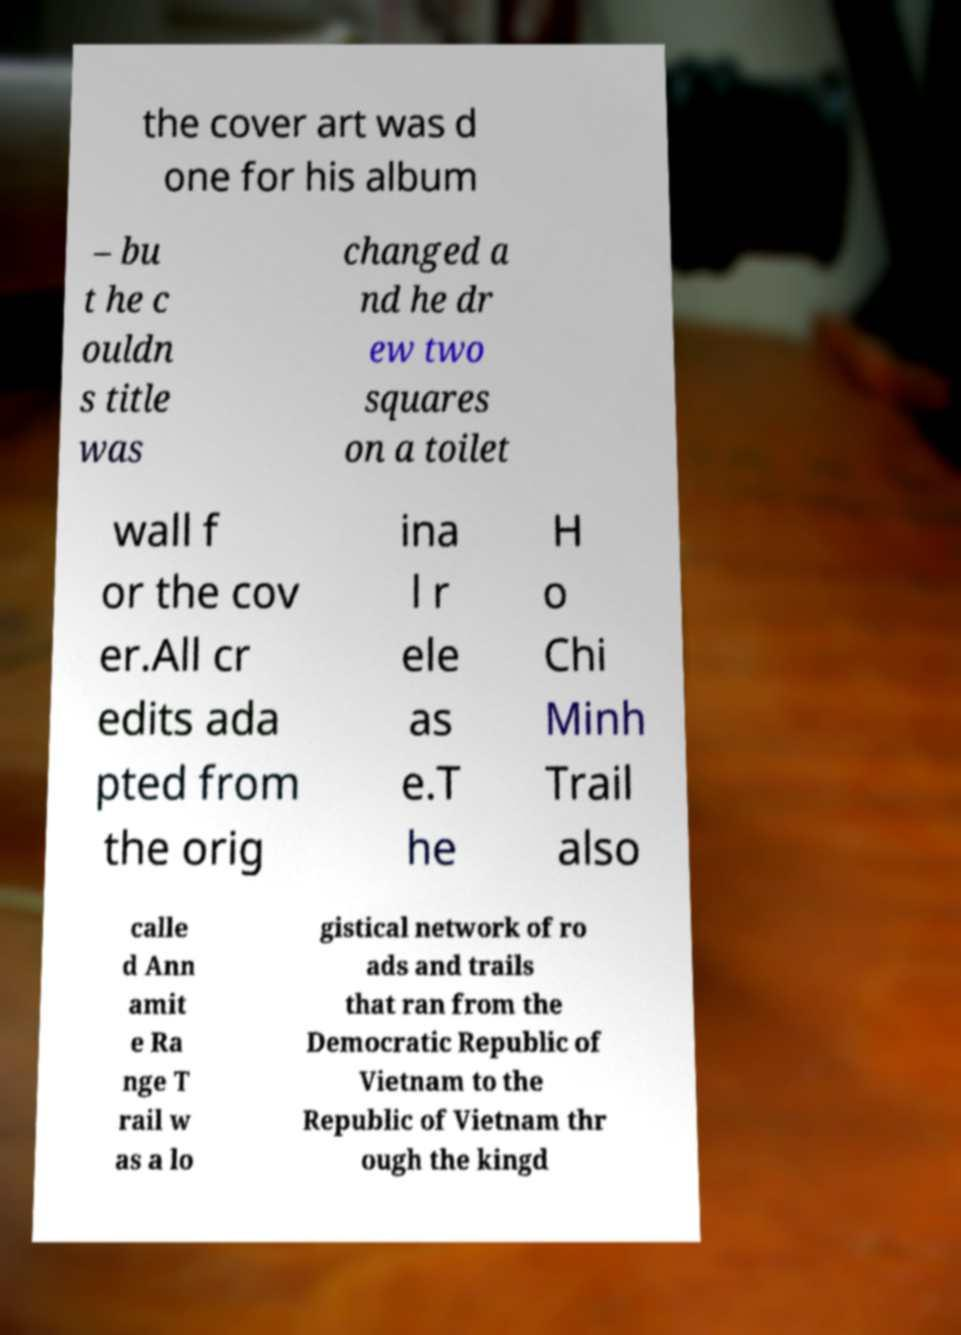Could you extract and type out the text from this image? the cover art was d one for his album – bu t he c ouldn s title was changed a nd he dr ew two squares on a toilet wall f or the cov er.All cr edits ada pted from the orig ina l r ele as e.T he H o Chi Minh Trail also calle d Ann amit e Ra nge T rail w as a lo gistical network of ro ads and trails that ran from the Democratic Republic of Vietnam to the Republic of Vietnam thr ough the kingd 